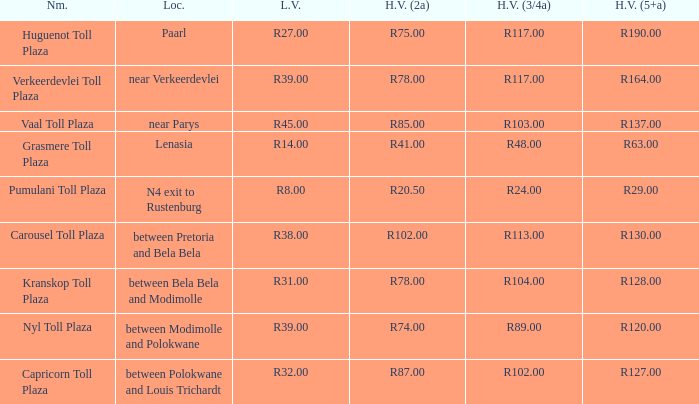What is the toll for light vehicles at the plaza between bela bela and modimolle? R31.00. 